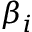Convert formula to latex. <formula><loc_0><loc_0><loc_500><loc_500>\beta _ { i }</formula> 